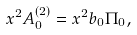Convert formula to latex. <formula><loc_0><loc_0><loc_500><loc_500>x ^ { 2 } A _ { 0 } ^ { ( 2 ) } = x ^ { 2 } b _ { 0 } \Pi _ { 0 } ,</formula> 